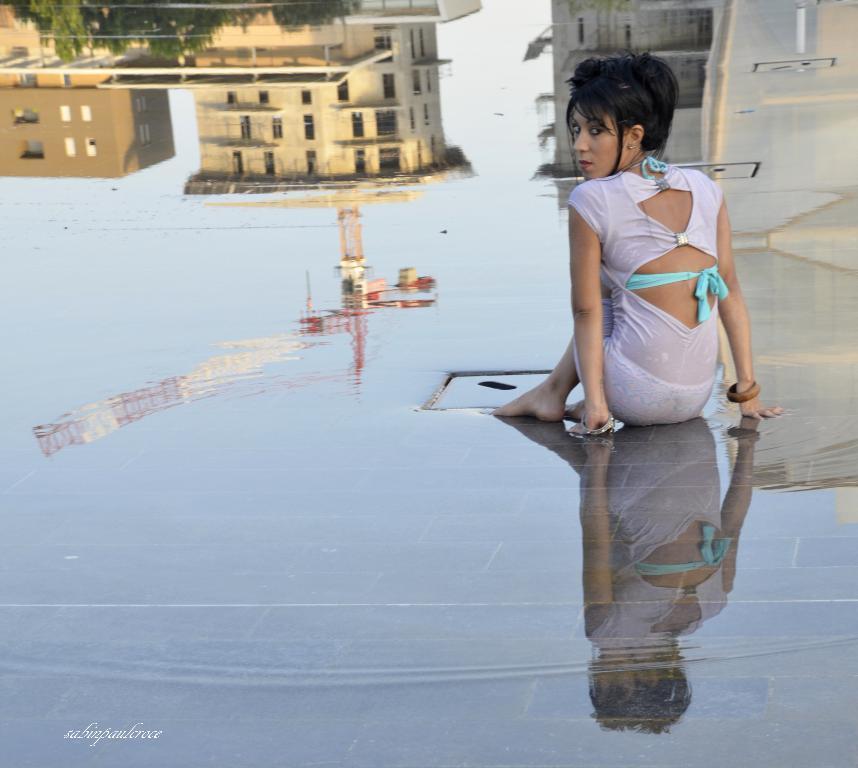In one or two sentences, can you explain what this image depicts? A girl is sitting on a wet surface wearing a white dress. There is a reflection of buildings and trees at the back on the water. 